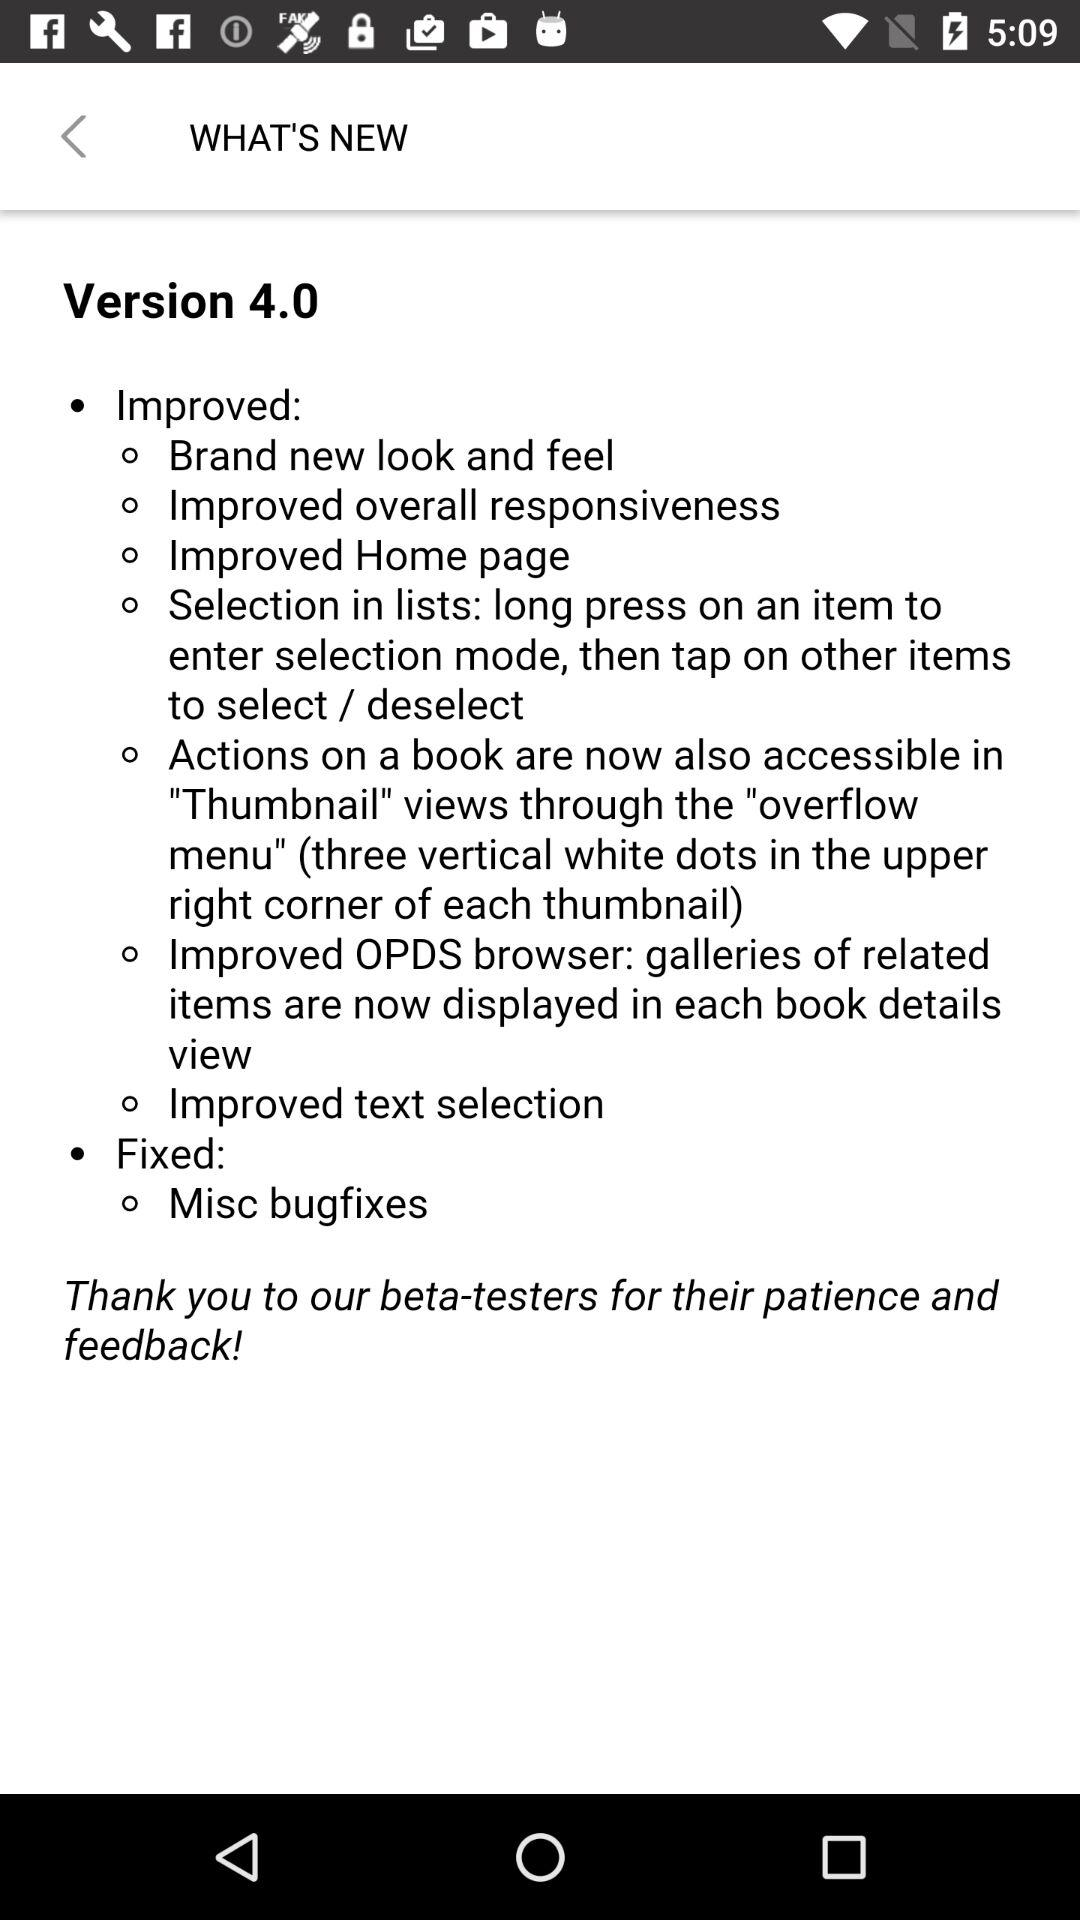What are the improved features in version 4.0 of the application? The improved features in version 4.0 of the application are "Brand new look and feel", "Improved overall responsiveness", "Improved Home page", "Selection in lists: long press on an item to enter selection mode, then tap on other items to select / deselect", "Actions on a book are now also accessible in "Thumbnail" views through the "overflow menu" (three vertical white dots in the upper right corner of each thumbnail)", "Improved OPDS browser: galleries of related items are now displayed in each book details view" and "Improved text selection". 